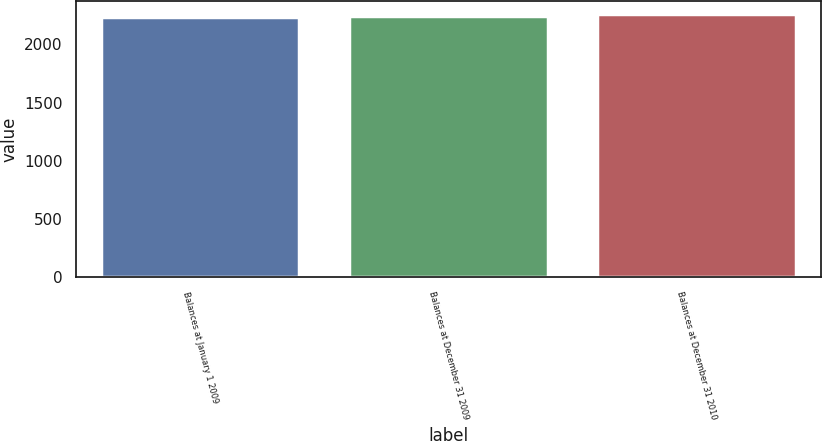<chart> <loc_0><loc_0><loc_500><loc_500><bar_chart><fcel>Balances at January 1 2009<fcel>Balances at December 31 2009<fcel>Balances at December 31 2010<nl><fcel>2239<fcel>2243<fcel>2262<nl></chart> 